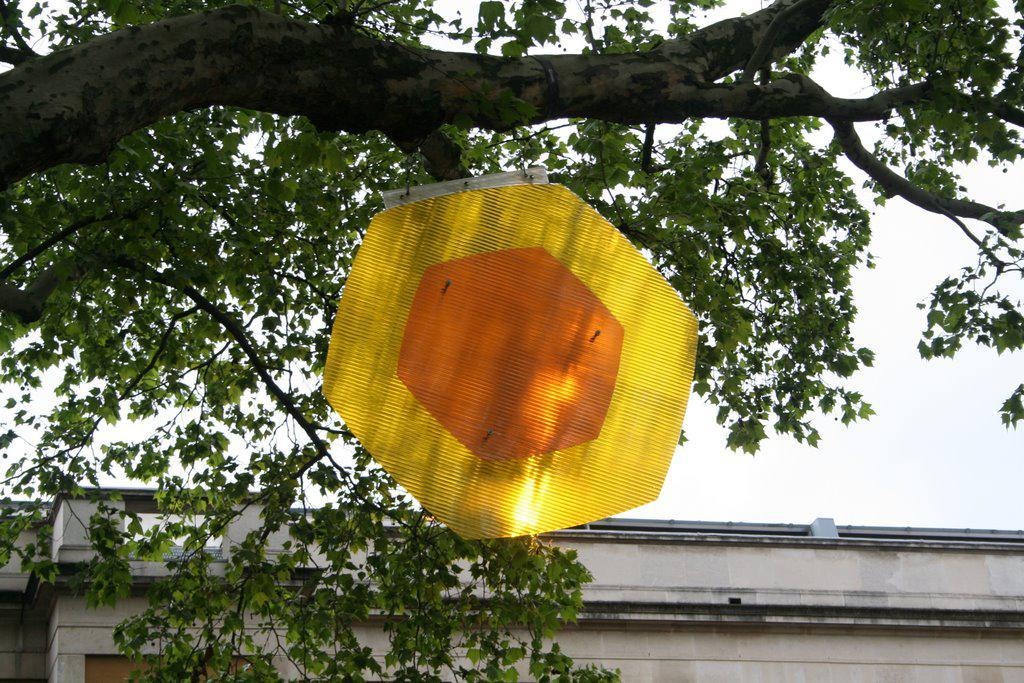What type of plant can be seen in the image? There is a tree in the image. What object is present in the image that is not a part of the tree or the building? There is a board in the image. What can be seen in the distance behind the tree and the board? There is a building in the background of the image. What part of the natural environment is visible in the image? The sky is visible in the background of the image. What type of store can be seen in the image? There is no store present in the image. Is there a bed visible in the image? There is no bed present in the image. 